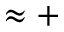<formula> <loc_0><loc_0><loc_500><loc_500>\approx +</formula> 